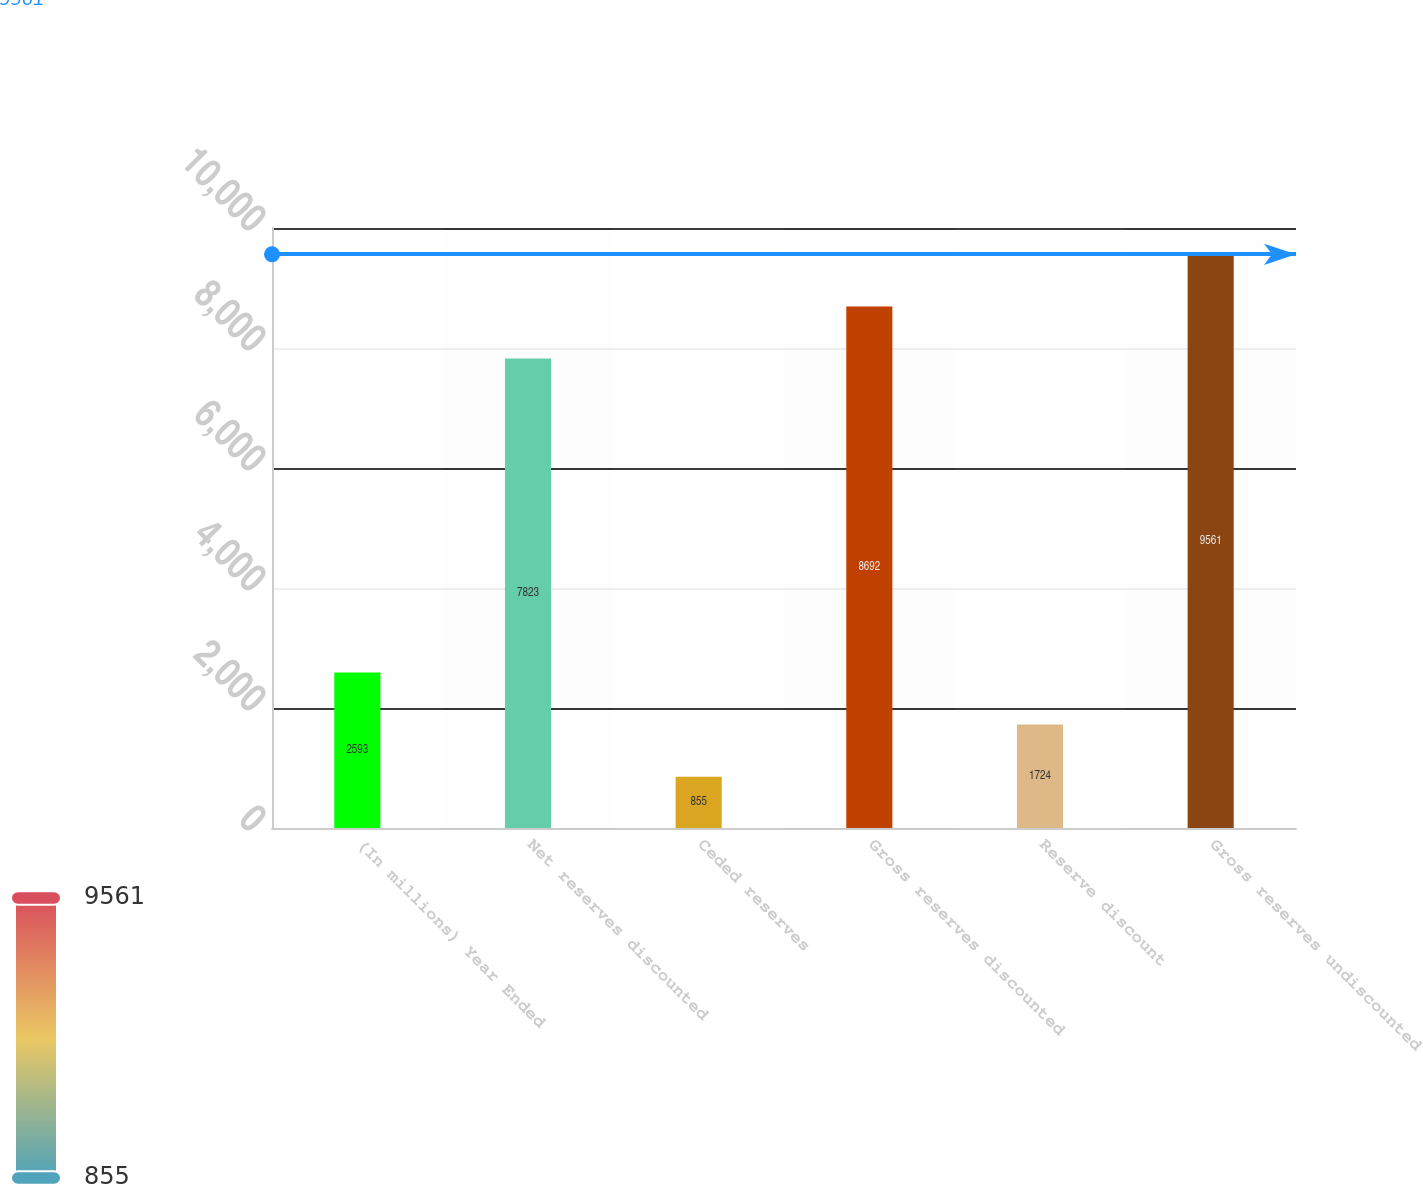Convert chart. <chart><loc_0><loc_0><loc_500><loc_500><bar_chart><fcel>(In millions) Year Ended<fcel>Net reserves discounted<fcel>Ceded reserves<fcel>Gross reserves discounted<fcel>Reserve discount<fcel>Gross reserves undiscounted<nl><fcel>2593<fcel>7823<fcel>855<fcel>8692<fcel>1724<fcel>9561<nl></chart> 